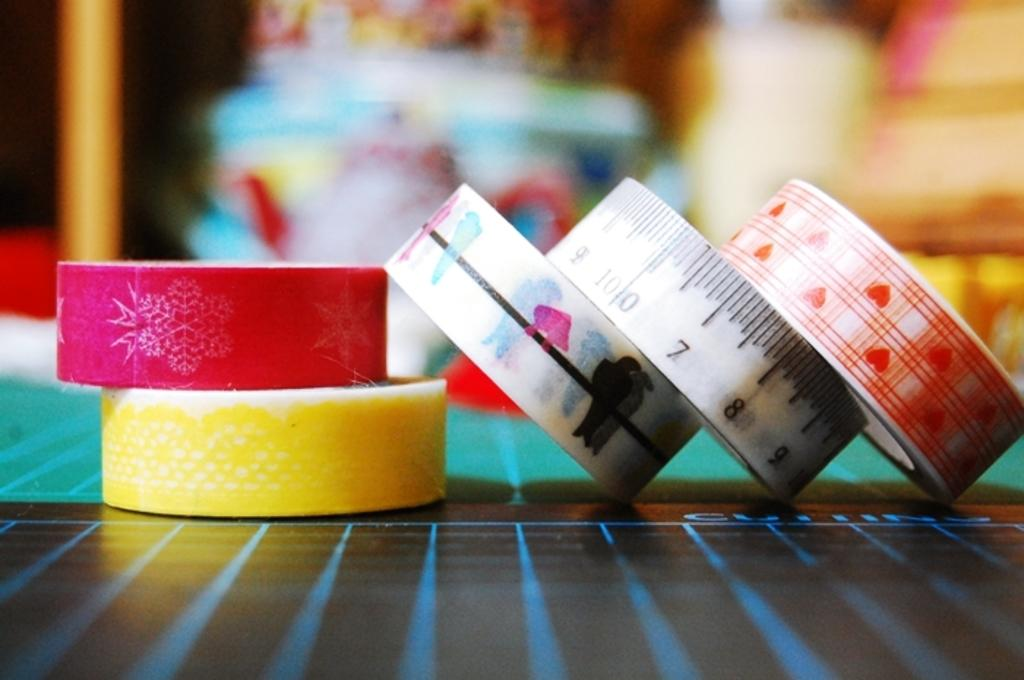How many pattern tapes are visible in the image? There are five pattern tapes in the image. What is present on the table in the image? There is a paper on the table. What is the background of the image like? The background appears colorful and is blurred. What type of cloud can be seen in the image? There are no clouds present in the image; the background is colorful and blurred, but it does not depict a cloud. 